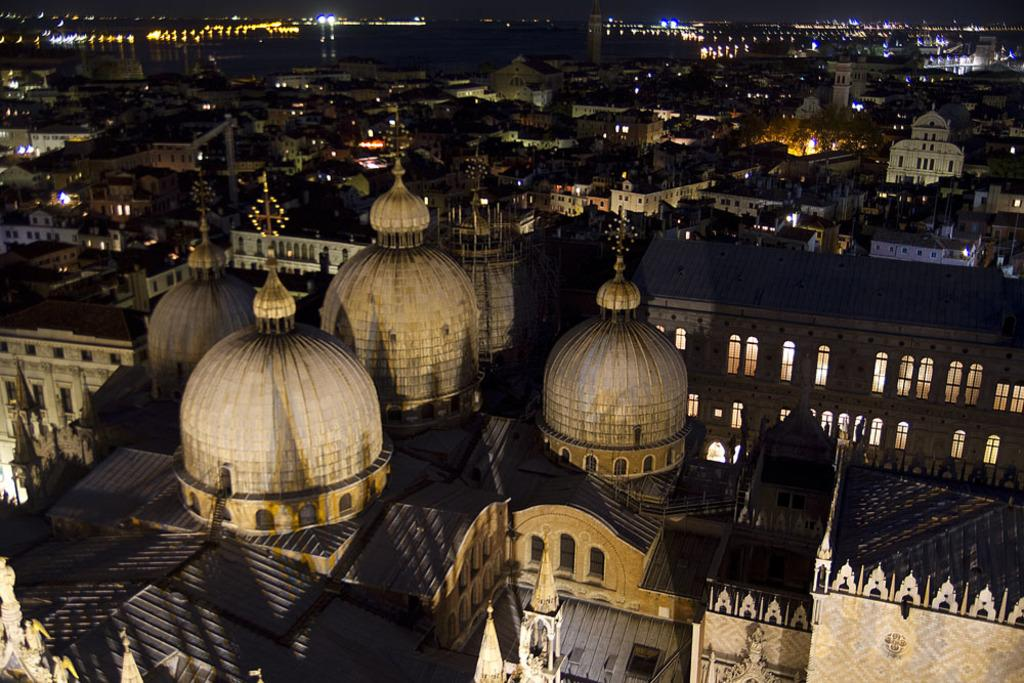What type of view is shown in the image? The image depicts a night view of the city. Can you identify any specific buildings in the image? Yes, there is a building at the bottom of the image that resembles a church. Are there any other buildings visible in the image? Yes, there are other buildings visible in the image. What feature is common among the buildings in the image? Lights are present in the image, indicating that the buildings are illuminated at night. Can you describe the snake that is slithering through the church in the image? There is no snake present in the image; it depicts a night view of the city with a church-like building and other illuminated buildings. 